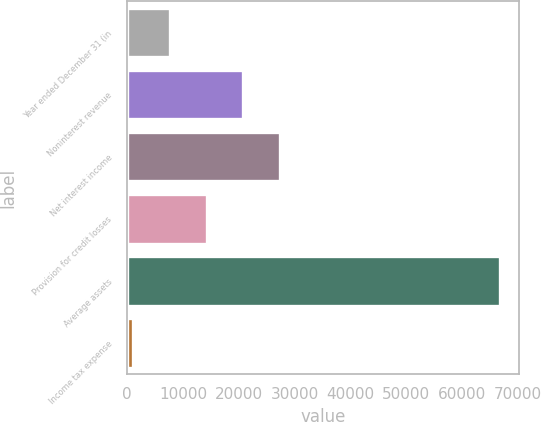Convert chart to OTSL. <chart><loc_0><loc_0><loc_500><loc_500><bar_chart><fcel>Year ended December 31 (in<fcel>Noninterest revenue<fcel>Net interest income<fcel>Provision for credit losses<fcel>Average assets<fcel>Income tax expense<nl><fcel>7632<fcel>20776<fcel>27348<fcel>14204<fcel>66780<fcel>1060<nl></chart> 